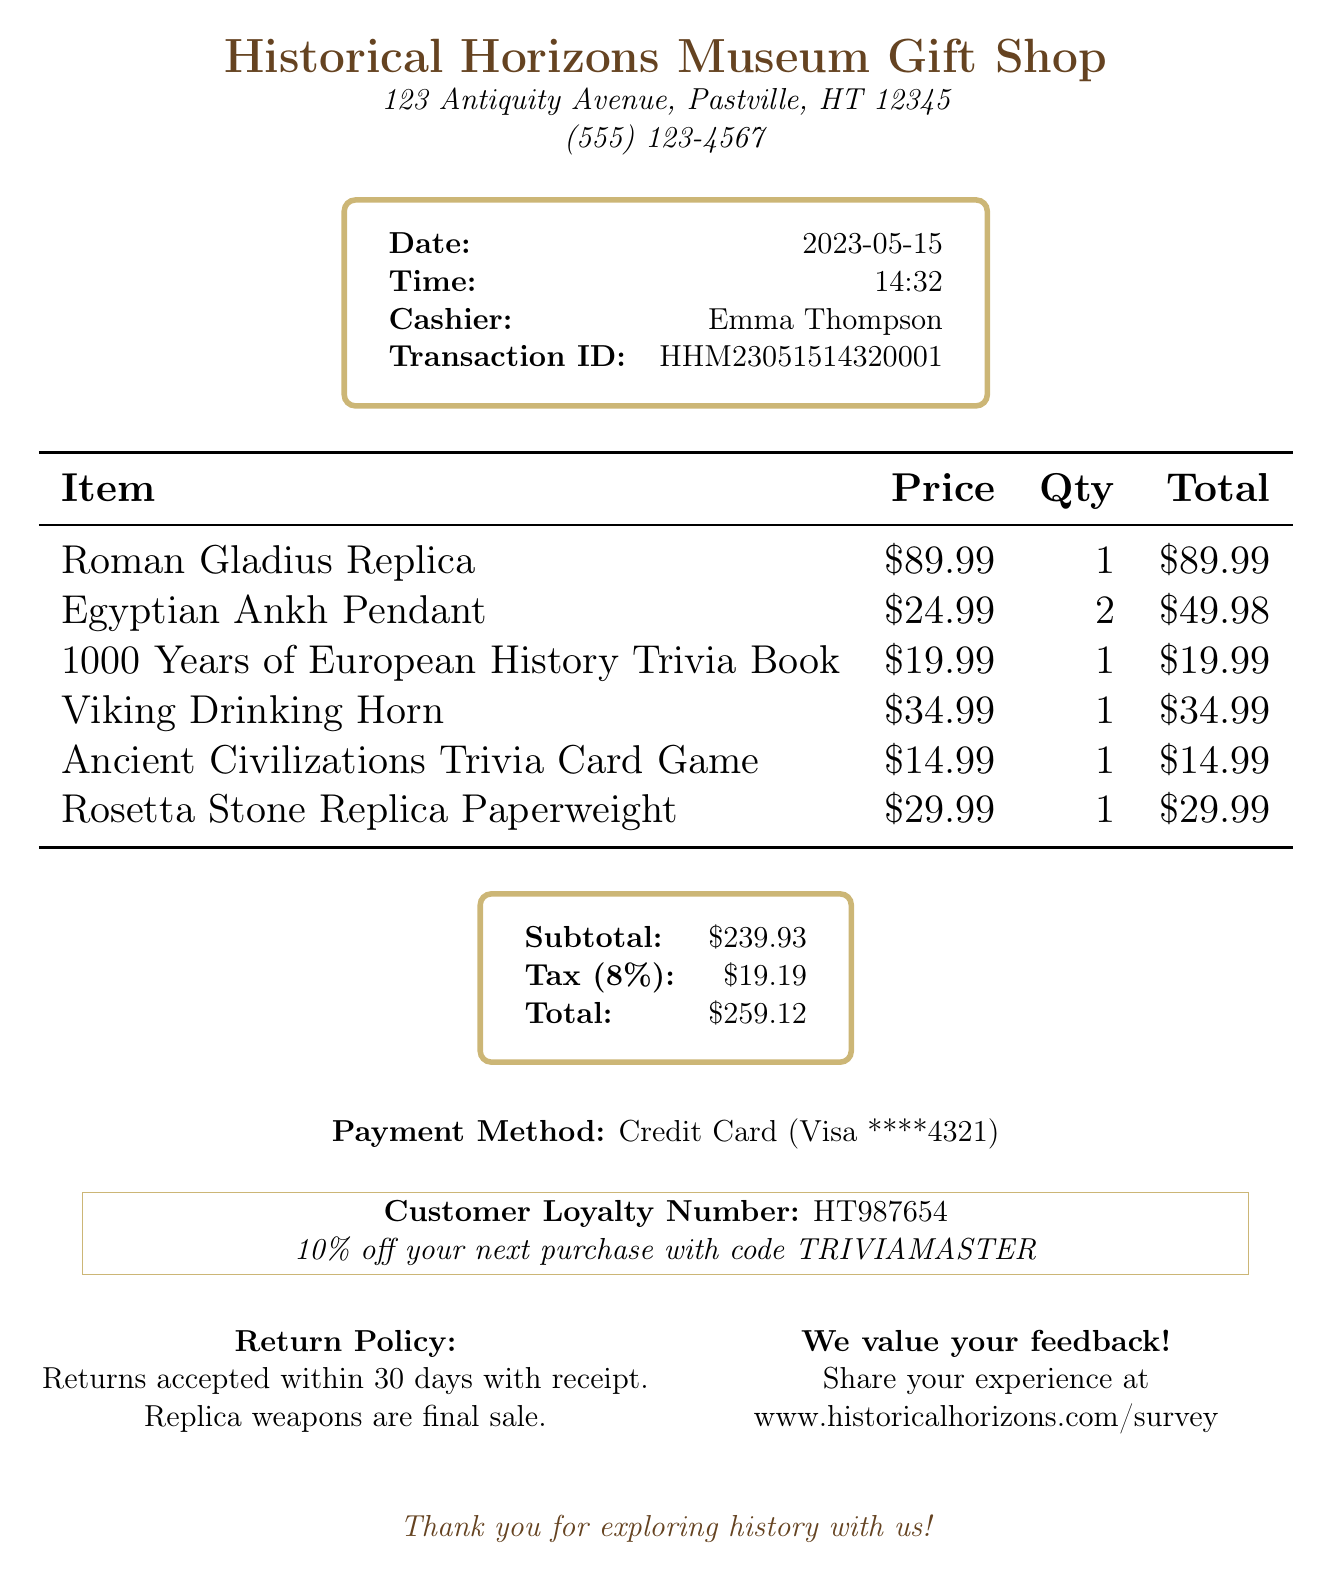What is the name of the store? The store's name is listed at the top of the document.
Answer: Historical Horizons Museum Gift Shop What date was the transaction made? The date of the transaction is mentioned in a designated field in the document.
Answer: 2023-05-15 Who was the cashier? The name of the cashier is provided in the transaction details section.
Answer: Emma Thompson What is the total price of the items purchased? The total price is clearly stated in the summary section of the document.
Answer: $259.12 How many Egyptian Ankh Pendants were bought? The quantity for the Egyptian Ankh Pendant is itemized in the receipt's table.
Answer: 2 What is the subtotal before tax? The subtotal is indicated in the summary section of the document.
Answer: $239.93 What percentage is the tax rate? The tax rate is specified in the document under tax details.
Answer: 8% What item is associated with a trivia book? The trivia book titled in the item list indicates its association with trivia.
Answer: 1000 Years of European History Trivia Book How can a customer provide feedback? The feedback invitation is prominently mentioned in the document.
Answer: www.historicalhorizons.com/survey 